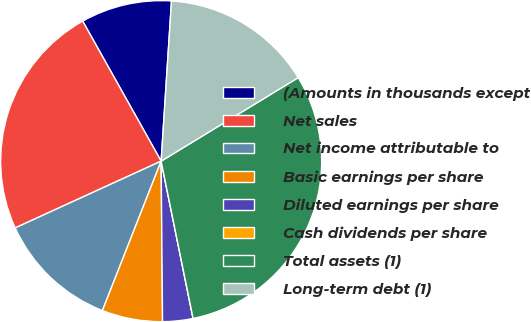Convert chart. <chart><loc_0><loc_0><loc_500><loc_500><pie_chart><fcel>(Amounts in thousands except<fcel>Net sales<fcel>Net income attributable to<fcel>Basic earnings per share<fcel>Diluted earnings per share<fcel>Cash dividends per share<fcel>Total assets (1)<fcel>Long-term debt (1)<nl><fcel>9.16%<fcel>23.7%<fcel>12.21%<fcel>6.1%<fcel>3.05%<fcel>0.0%<fcel>30.52%<fcel>15.26%<nl></chart> 